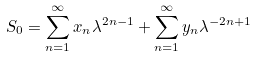<formula> <loc_0><loc_0><loc_500><loc_500>S _ { 0 } = \sum _ { n = 1 } ^ { \infty } x _ { n } \lambda ^ { 2 n - 1 } + \sum _ { n = 1 } ^ { \infty } y _ { n } \lambda ^ { - 2 n + 1 }</formula> 